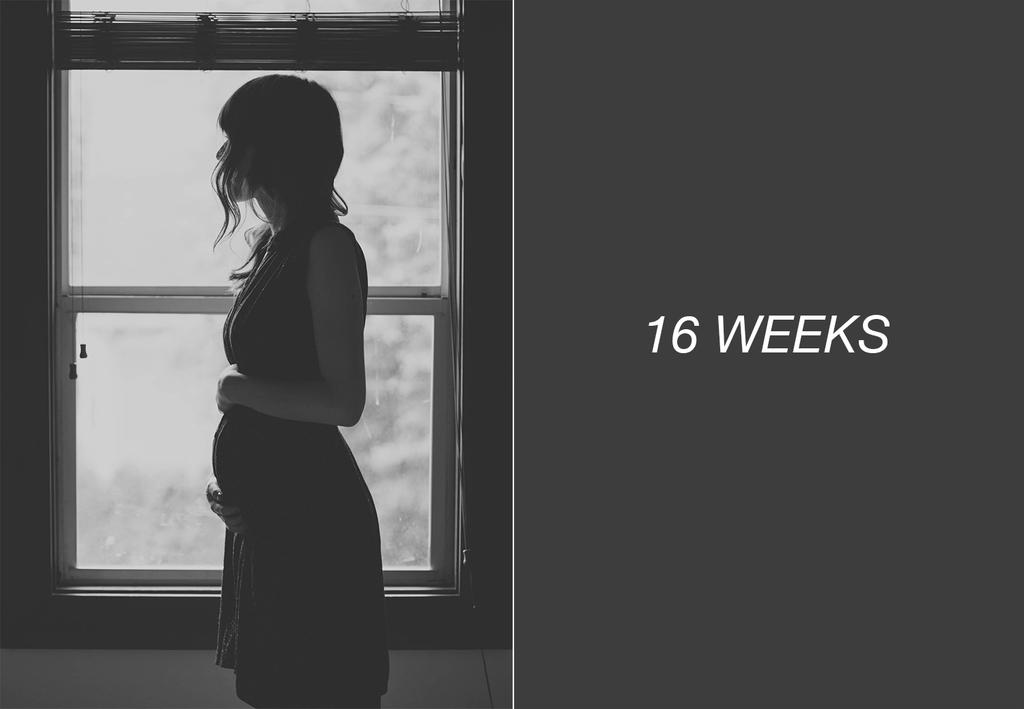Who is present in the image? There is a woman in the image. Where is the woman located in relation to the window? The woman is standing near a window. What can be seen on the right side of the image? There is text and numbers on the right side of the image. How many dolls are sitting on the earth in the image? There are no dolls or earth present in the image. 